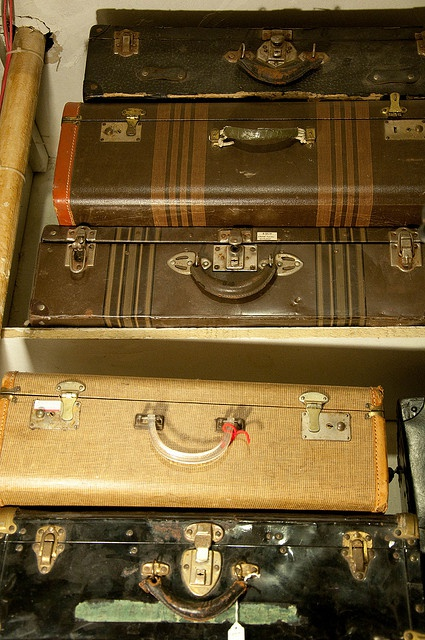Describe the objects in this image and their specific colors. I can see suitcase in tan, black, maroon, and olive tones and suitcase in tan, black, olive, darkgreen, and gray tones in this image. 